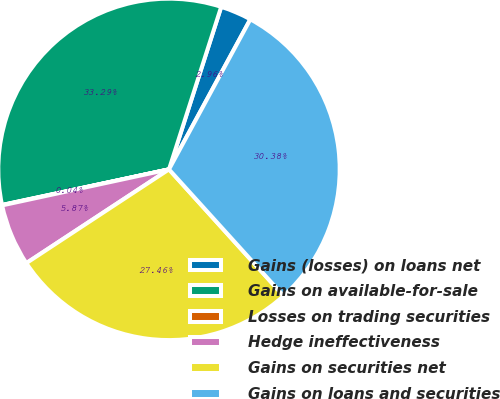Convert chart to OTSL. <chart><loc_0><loc_0><loc_500><loc_500><pie_chart><fcel>Gains (losses) on loans net<fcel>Gains on available-for-sale<fcel>Losses on trading securities<fcel>Hedge ineffectiveness<fcel>Gains on securities net<fcel>Gains on loans and securities<nl><fcel>2.96%<fcel>33.29%<fcel>0.04%<fcel>5.87%<fcel>27.46%<fcel>30.38%<nl></chart> 